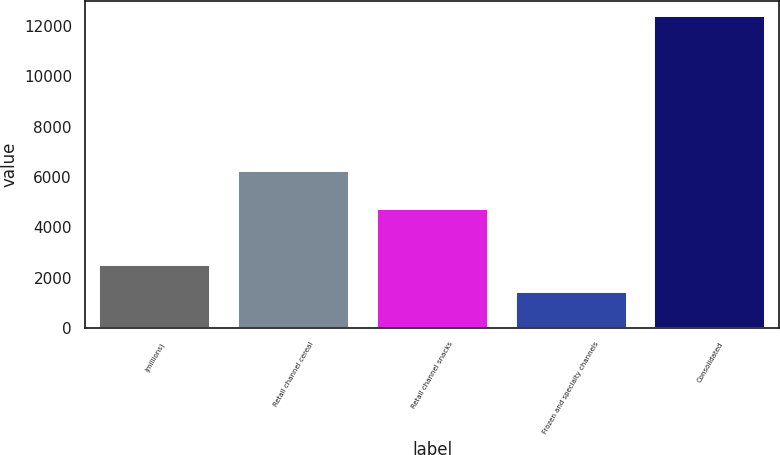<chart> <loc_0><loc_0><loc_500><loc_500><bar_chart><fcel>(millions)<fcel>Retail channel cereal<fcel>Retail channel snacks<fcel>Frozen and specialty channels<fcel>Consolidated<nl><fcel>2506<fcel>6256<fcel>4734<fcel>1407<fcel>12397<nl></chart> 